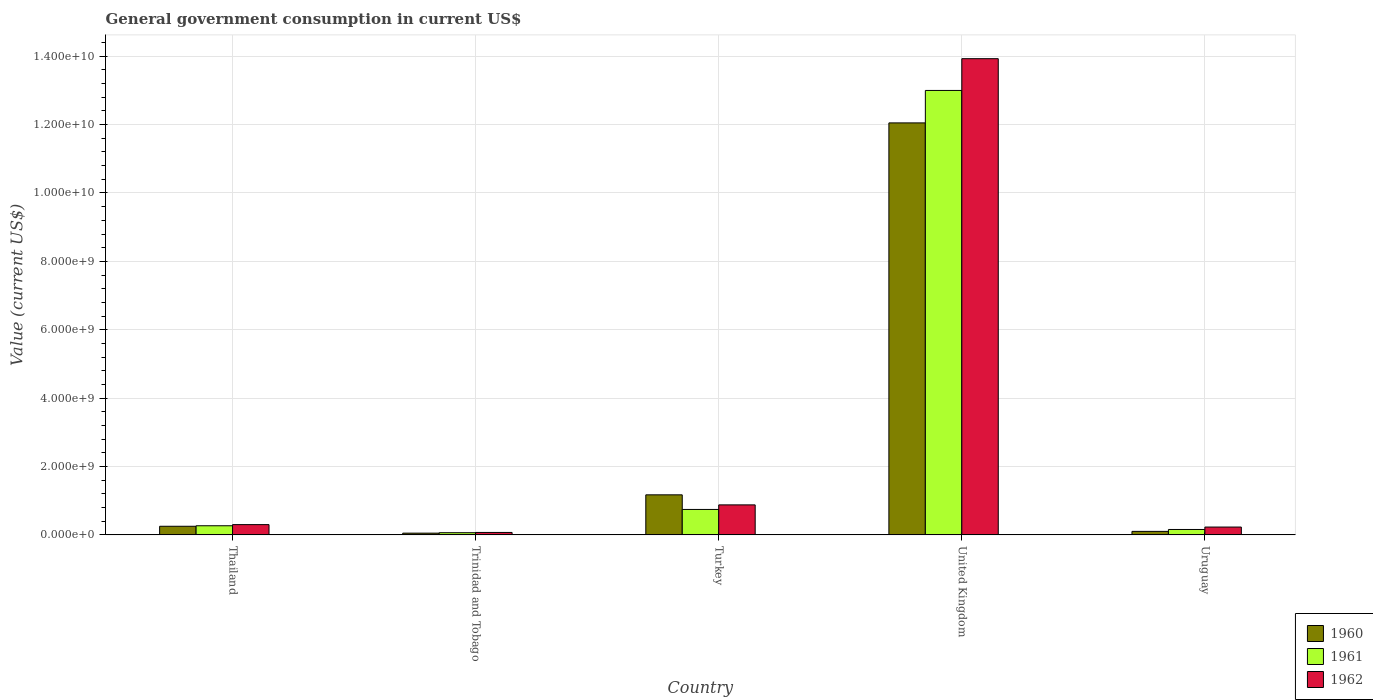How many different coloured bars are there?
Offer a terse response. 3. Are the number of bars on each tick of the X-axis equal?
Your answer should be very brief. Yes. How many bars are there on the 5th tick from the left?
Offer a terse response. 3. What is the government conusmption in 1961 in Uruguay?
Your response must be concise. 1.58e+08. Across all countries, what is the maximum government conusmption in 1961?
Provide a short and direct response. 1.30e+1. Across all countries, what is the minimum government conusmption in 1960?
Provide a succinct answer. 5.12e+07. In which country was the government conusmption in 1961 minimum?
Offer a very short reply. Trinidad and Tobago. What is the total government conusmption in 1960 in the graph?
Make the answer very short. 1.36e+1. What is the difference between the government conusmption in 1962 in Trinidad and Tobago and that in Turkey?
Your answer should be very brief. -8.06e+08. What is the difference between the government conusmption in 1961 in Turkey and the government conusmption in 1960 in Uruguay?
Give a very brief answer. 6.42e+08. What is the average government conusmption in 1962 per country?
Your answer should be very brief. 3.08e+09. What is the difference between the government conusmption of/in 1962 and government conusmption of/in 1961 in Trinidad and Tobago?
Your answer should be compact. 7.70e+06. What is the ratio of the government conusmption in 1961 in Thailand to that in United Kingdom?
Give a very brief answer. 0.02. Is the difference between the government conusmption in 1962 in Thailand and Trinidad and Tobago greater than the difference between the government conusmption in 1961 in Thailand and Trinidad and Tobago?
Your response must be concise. Yes. What is the difference between the highest and the second highest government conusmption in 1960?
Keep it short and to the point. 9.19e+08. What is the difference between the highest and the lowest government conusmption in 1961?
Provide a short and direct response. 1.29e+1. Is the sum of the government conusmption in 1962 in Turkey and United Kingdom greater than the maximum government conusmption in 1961 across all countries?
Provide a succinct answer. Yes. What does the 1st bar from the left in United Kingdom represents?
Your answer should be very brief. 1960. What does the 3rd bar from the right in Trinidad and Tobago represents?
Offer a terse response. 1960. Is it the case that in every country, the sum of the government conusmption in 1962 and government conusmption in 1961 is greater than the government conusmption in 1960?
Provide a succinct answer. Yes. How many bars are there?
Give a very brief answer. 15. What is the difference between two consecutive major ticks on the Y-axis?
Offer a terse response. 2.00e+09. Are the values on the major ticks of Y-axis written in scientific E-notation?
Make the answer very short. Yes. Does the graph contain any zero values?
Your response must be concise. No. Where does the legend appear in the graph?
Provide a succinct answer. Bottom right. How are the legend labels stacked?
Provide a short and direct response. Vertical. What is the title of the graph?
Ensure brevity in your answer.  General government consumption in current US$. Does "2014" appear as one of the legend labels in the graph?
Your response must be concise. No. What is the label or title of the Y-axis?
Keep it short and to the point. Value (current US$). What is the Value (current US$) in 1960 in Thailand?
Ensure brevity in your answer.  2.52e+08. What is the Value (current US$) of 1961 in Thailand?
Provide a succinct answer. 2.67e+08. What is the Value (current US$) of 1962 in Thailand?
Make the answer very short. 3.01e+08. What is the Value (current US$) of 1960 in Trinidad and Tobago?
Give a very brief answer. 5.12e+07. What is the Value (current US$) of 1961 in Trinidad and Tobago?
Offer a terse response. 6.39e+07. What is the Value (current US$) of 1962 in Trinidad and Tobago?
Provide a short and direct response. 7.16e+07. What is the Value (current US$) in 1960 in Turkey?
Offer a very short reply. 1.17e+09. What is the Value (current US$) in 1961 in Turkey?
Make the answer very short. 7.44e+08. What is the Value (current US$) of 1962 in Turkey?
Your answer should be very brief. 8.78e+08. What is the Value (current US$) in 1960 in United Kingdom?
Provide a succinct answer. 1.20e+1. What is the Value (current US$) in 1961 in United Kingdom?
Your answer should be very brief. 1.30e+1. What is the Value (current US$) in 1962 in United Kingdom?
Give a very brief answer. 1.39e+1. What is the Value (current US$) of 1960 in Uruguay?
Offer a terse response. 1.03e+08. What is the Value (current US$) of 1961 in Uruguay?
Make the answer very short. 1.58e+08. What is the Value (current US$) in 1962 in Uruguay?
Your response must be concise. 2.29e+08. Across all countries, what is the maximum Value (current US$) of 1960?
Offer a terse response. 1.20e+1. Across all countries, what is the maximum Value (current US$) in 1961?
Ensure brevity in your answer.  1.30e+1. Across all countries, what is the maximum Value (current US$) in 1962?
Provide a short and direct response. 1.39e+1. Across all countries, what is the minimum Value (current US$) of 1960?
Ensure brevity in your answer.  5.12e+07. Across all countries, what is the minimum Value (current US$) of 1961?
Your answer should be very brief. 6.39e+07. Across all countries, what is the minimum Value (current US$) in 1962?
Ensure brevity in your answer.  7.16e+07. What is the total Value (current US$) of 1960 in the graph?
Make the answer very short. 1.36e+1. What is the total Value (current US$) of 1961 in the graph?
Offer a very short reply. 1.42e+1. What is the total Value (current US$) in 1962 in the graph?
Your answer should be compact. 1.54e+1. What is the difference between the Value (current US$) in 1960 in Thailand and that in Trinidad and Tobago?
Provide a succinct answer. 2.01e+08. What is the difference between the Value (current US$) in 1961 in Thailand and that in Trinidad and Tobago?
Your answer should be compact. 2.03e+08. What is the difference between the Value (current US$) of 1962 in Thailand and that in Trinidad and Tobago?
Offer a terse response. 2.29e+08. What is the difference between the Value (current US$) of 1960 in Thailand and that in Turkey?
Provide a succinct answer. -9.19e+08. What is the difference between the Value (current US$) in 1961 in Thailand and that in Turkey?
Your answer should be very brief. -4.77e+08. What is the difference between the Value (current US$) of 1962 in Thailand and that in Turkey?
Make the answer very short. -5.77e+08. What is the difference between the Value (current US$) of 1960 in Thailand and that in United Kingdom?
Ensure brevity in your answer.  -1.18e+1. What is the difference between the Value (current US$) of 1961 in Thailand and that in United Kingdom?
Your response must be concise. -1.27e+1. What is the difference between the Value (current US$) of 1962 in Thailand and that in United Kingdom?
Provide a short and direct response. -1.36e+1. What is the difference between the Value (current US$) in 1960 in Thailand and that in Uruguay?
Make the answer very short. 1.49e+08. What is the difference between the Value (current US$) of 1961 in Thailand and that in Uruguay?
Offer a terse response. 1.09e+08. What is the difference between the Value (current US$) in 1962 in Thailand and that in Uruguay?
Your answer should be compact. 7.16e+07. What is the difference between the Value (current US$) of 1960 in Trinidad and Tobago and that in Turkey?
Give a very brief answer. -1.12e+09. What is the difference between the Value (current US$) of 1961 in Trinidad and Tobago and that in Turkey?
Offer a very short reply. -6.81e+08. What is the difference between the Value (current US$) in 1962 in Trinidad and Tobago and that in Turkey?
Your response must be concise. -8.06e+08. What is the difference between the Value (current US$) of 1960 in Trinidad and Tobago and that in United Kingdom?
Your answer should be very brief. -1.20e+1. What is the difference between the Value (current US$) in 1961 in Trinidad and Tobago and that in United Kingdom?
Offer a very short reply. -1.29e+1. What is the difference between the Value (current US$) of 1962 in Trinidad and Tobago and that in United Kingdom?
Your answer should be very brief. -1.39e+1. What is the difference between the Value (current US$) in 1960 in Trinidad and Tobago and that in Uruguay?
Your answer should be very brief. -5.16e+07. What is the difference between the Value (current US$) in 1961 in Trinidad and Tobago and that in Uruguay?
Your answer should be compact. -9.44e+07. What is the difference between the Value (current US$) in 1962 in Trinidad and Tobago and that in Uruguay?
Give a very brief answer. -1.58e+08. What is the difference between the Value (current US$) in 1960 in Turkey and that in United Kingdom?
Provide a short and direct response. -1.09e+1. What is the difference between the Value (current US$) in 1961 in Turkey and that in United Kingdom?
Offer a very short reply. -1.23e+1. What is the difference between the Value (current US$) of 1962 in Turkey and that in United Kingdom?
Your response must be concise. -1.30e+1. What is the difference between the Value (current US$) of 1960 in Turkey and that in Uruguay?
Make the answer very short. 1.07e+09. What is the difference between the Value (current US$) in 1961 in Turkey and that in Uruguay?
Provide a short and direct response. 5.86e+08. What is the difference between the Value (current US$) in 1962 in Turkey and that in Uruguay?
Give a very brief answer. 6.49e+08. What is the difference between the Value (current US$) of 1960 in United Kingdom and that in Uruguay?
Your answer should be very brief. 1.19e+1. What is the difference between the Value (current US$) in 1961 in United Kingdom and that in Uruguay?
Provide a short and direct response. 1.28e+1. What is the difference between the Value (current US$) of 1962 in United Kingdom and that in Uruguay?
Your response must be concise. 1.37e+1. What is the difference between the Value (current US$) of 1960 in Thailand and the Value (current US$) of 1961 in Trinidad and Tobago?
Your answer should be compact. 1.88e+08. What is the difference between the Value (current US$) in 1960 in Thailand and the Value (current US$) in 1962 in Trinidad and Tobago?
Provide a succinct answer. 1.81e+08. What is the difference between the Value (current US$) of 1961 in Thailand and the Value (current US$) of 1962 in Trinidad and Tobago?
Give a very brief answer. 1.96e+08. What is the difference between the Value (current US$) in 1960 in Thailand and the Value (current US$) in 1961 in Turkey?
Offer a very short reply. -4.92e+08. What is the difference between the Value (current US$) in 1960 in Thailand and the Value (current US$) in 1962 in Turkey?
Keep it short and to the point. -6.26e+08. What is the difference between the Value (current US$) of 1961 in Thailand and the Value (current US$) of 1962 in Turkey?
Provide a succinct answer. -6.11e+08. What is the difference between the Value (current US$) of 1960 in Thailand and the Value (current US$) of 1961 in United Kingdom?
Provide a succinct answer. -1.27e+1. What is the difference between the Value (current US$) of 1960 in Thailand and the Value (current US$) of 1962 in United Kingdom?
Offer a very short reply. -1.37e+1. What is the difference between the Value (current US$) of 1961 in Thailand and the Value (current US$) of 1962 in United Kingdom?
Your response must be concise. -1.37e+1. What is the difference between the Value (current US$) in 1960 in Thailand and the Value (current US$) in 1961 in Uruguay?
Your response must be concise. 9.39e+07. What is the difference between the Value (current US$) of 1960 in Thailand and the Value (current US$) of 1962 in Uruguay?
Make the answer very short. 2.30e+07. What is the difference between the Value (current US$) of 1961 in Thailand and the Value (current US$) of 1962 in Uruguay?
Give a very brief answer. 3.80e+07. What is the difference between the Value (current US$) of 1960 in Trinidad and Tobago and the Value (current US$) of 1961 in Turkey?
Offer a very short reply. -6.93e+08. What is the difference between the Value (current US$) in 1960 in Trinidad and Tobago and the Value (current US$) in 1962 in Turkey?
Your response must be concise. -8.27e+08. What is the difference between the Value (current US$) in 1961 in Trinidad and Tobago and the Value (current US$) in 1962 in Turkey?
Your answer should be very brief. -8.14e+08. What is the difference between the Value (current US$) in 1960 in Trinidad and Tobago and the Value (current US$) in 1961 in United Kingdom?
Provide a succinct answer. -1.29e+1. What is the difference between the Value (current US$) of 1960 in Trinidad and Tobago and the Value (current US$) of 1962 in United Kingdom?
Make the answer very short. -1.39e+1. What is the difference between the Value (current US$) of 1961 in Trinidad and Tobago and the Value (current US$) of 1962 in United Kingdom?
Your response must be concise. -1.39e+1. What is the difference between the Value (current US$) in 1960 in Trinidad and Tobago and the Value (current US$) in 1961 in Uruguay?
Offer a terse response. -1.07e+08. What is the difference between the Value (current US$) of 1960 in Trinidad and Tobago and the Value (current US$) of 1962 in Uruguay?
Keep it short and to the point. -1.78e+08. What is the difference between the Value (current US$) of 1961 in Trinidad and Tobago and the Value (current US$) of 1962 in Uruguay?
Offer a terse response. -1.65e+08. What is the difference between the Value (current US$) of 1960 in Turkey and the Value (current US$) of 1961 in United Kingdom?
Provide a succinct answer. -1.18e+1. What is the difference between the Value (current US$) of 1960 in Turkey and the Value (current US$) of 1962 in United Kingdom?
Your response must be concise. -1.28e+1. What is the difference between the Value (current US$) in 1961 in Turkey and the Value (current US$) in 1962 in United Kingdom?
Keep it short and to the point. -1.32e+1. What is the difference between the Value (current US$) in 1960 in Turkey and the Value (current US$) in 1961 in Uruguay?
Your answer should be very brief. 1.01e+09. What is the difference between the Value (current US$) in 1960 in Turkey and the Value (current US$) in 1962 in Uruguay?
Offer a terse response. 9.42e+08. What is the difference between the Value (current US$) in 1961 in Turkey and the Value (current US$) in 1962 in Uruguay?
Keep it short and to the point. 5.15e+08. What is the difference between the Value (current US$) of 1960 in United Kingdom and the Value (current US$) of 1961 in Uruguay?
Make the answer very short. 1.19e+1. What is the difference between the Value (current US$) of 1960 in United Kingdom and the Value (current US$) of 1962 in Uruguay?
Provide a short and direct response. 1.18e+1. What is the difference between the Value (current US$) of 1961 in United Kingdom and the Value (current US$) of 1962 in Uruguay?
Make the answer very short. 1.28e+1. What is the average Value (current US$) of 1960 per country?
Ensure brevity in your answer.  2.73e+09. What is the average Value (current US$) of 1961 per country?
Make the answer very short. 2.85e+09. What is the average Value (current US$) in 1962 per country?
Your answer should be compact. 3.08e+09. What is the difference between the Value (current US$) in 1960 and Value (current US$) in 1961 in Thailand?
Ensure brevity in your answer.  -1.50e+07. What is the difference between the Value (current US$) in 1960 and Value (current US$) in 1962 in Thailand?
Keep it short and to the point. -4.86e+07. What is the difference between the Value (current US$) of 1961 and Value (current US$) of 1962 in Thailand?
Your response must be concise. -3.36e+07. What is the difference between the Value (current US$) in 1960 and Value (current US$) in 1961 in Trinidad and Tobago?
Give a very brief answer. -1.27e+07. What is the difference between the Value (current US$) in 1960 and Value (current US$) in 1962 in Trinidad and Tobago?
Your answer should be very brief. -2.04e+07. What is the difference between the Value (current US$) in 1961 and Value (current US$) in 1962 in Trinidad and Tobago?
Your response must be concise. -7.70e+06. What is the difference between the Value (current US$) of 1960 and Value (current US$) of 1961 in Turkey?
Your answer should be compact. 4.27e+08. What is the difference between the Value (current US$) in 1960 and Value (current US$) in 1962 in Turkey?
Make the answer very short. 2.94e+08. What is the difference between the Value (current US$) in 1961 and Value (current US$) in 1962 in Turkey?
Give a very brief answer. -1.33e+08. What is the difference between the Value (current US$) of 1960 and Value (current US$) of 1961 in United Kingdom?
Provide a succinct answer. -9.49e+08. What is the difference between the Value (current US$) of 1960 and Value (current US$) of 1962 in United Kingdom?
Your response must be concise. -1.88e+09. What is the difference between the Value (current US$) of 1961 and Value (current US$) of 1962 in United Kingdom?
Provide a short and direct response. -9.29e+08. What is the difference between the Value (current US$) in 1960 and Value (current US$) in 1961 in Uruguay?
Your answer should be compact. -5.54e+07. What is the difference between the Value (current US$) in 1960 and Value (current US$) in 1962 in Uruguay?
Provide a succinct answer. -1.26e+08. What is the difference between the Value (current US$) of 1961 and Value (current US$) of 1962 in Uruguay?
Keep it short and to the point. -7.09e+07. What is the ratio of the Value (current US$) of 1960 in Thailand to that in Trinidad and Tobago?
Your response must be concise. 4.92. What is the ratio of the Value (current US$) of 1961 in Thailand to that in Trinidad and Tobago?
Make the answer very short. 4.18. What is the ratio of the Value (current US$) of 1962 in Thailand to that in Trinidad and Tobago?
Offer a terse response. 4.2. What is the ratio of the Value (current US$) in 1960 in Thailand to that in Turkey?
Give a very brief answer. 0.22. What is the ratio of the Value (current US$) in 1961 in Thailand to that in Turkey?
Offer a terse response. 0.36. What is the ratio of the Value (current US$) of 1962 in Thailand to that in Turkey?
Ensure brevity in your answer.  0.34. What is the ratio of the Value (current US$) in 1960 in Thailand to that in United Kingdom?
Offer a terse response. 0.02. What is the ratio of the Value (current US$) in 1961 in Thailand to that in United Kingdom?
Keep it short and to the point. 0.02. What is the ratio of the Value (current US$) of 1962 in Thailand to that in United Kingdom?
Your response must be concise. 0.02. What is the ratio of the Value (current US$) of 1960 in Thailand to that in Uruguay?
Offer a terse response. 2.45. What is the ratio of the Value (current US$) of 1961 in Thailand to that in Uruguay?
Provide a succinct answer. 1.69. What is the ratio of the Value (current US$) of 1962 in Thailand to that in Uruguay?
Offer a terse response. 1.31. What is the ratio of the Value (current US$) in 1960 in Trinidad and Tobago to that in Turkey?
Offer a very short reply. 0.04. What is the ratio of the Value (current US$) in 1961 in Trinidad and Tobago to that in Turkey?
Your answer should be compact. 0.09. What is the ratio of the Value (current US$) in 1962 in Trinidad and Tobago to that in Turkey?
Provide a succinct answer. 0.08. What is the ratio of the Value (current US$) of 1960 in Trinidad and Tobago to that in United Kingdom?
Your answer should be very brief. 0. What is the ratio of the Value (current US$) of 1961 in Trinidad and Tobago to that in United Kingdom?
Your answer should be very brief. 0. What is the ratio of the Value (current US$) in 1962 in Trinidad and Tobago to that in United Kingdom?
Make the answer very short. 0.01. What is the ratio of the Value (current US$) in 1960 in Trinidad and Tobago to that in Uruguay?
Give a very brief answer. 0.5. What is the ratio of the Value (current US$) of 1961 in Trinidad and Tobago to that in Uruguay?
Ensure brevity in your answer.  0.4. What is the ratio of the Value (current US$) in 1962 in Trinidad and Tobago to that in Uruguay?
Make the answer very short. 0.31. What is the ratio of the Value (current US$) of 1960 in Turkey to that in United Kingdom?
Make the answer very short. 0.1. What is the ratio of the Value (current US$) in 1961 in Turkey to that in United Kingdom?
Make the answer very short. 0.06. What is the ratio of the Value (current US$) in 1962 in Turkey to that in United Kingdom?
Make the answer very short. 0.06. What is the ratio of the Value (current US$) in 1960 in Turkey to that in Uruguay?
Provide a short and direct response. 11.39. What is the ratio of the Value (current US$) in 1961 in Turkey to that in Uruguay?
Offer a terse response. 4.7. What is the ratio of the Value (current US$) in 1962 in Turkey to that in Uruguay?
Make the answer very short. 3.83. What is the ratio of the Value (current US$) in 1960 in United Kingdom to that in Uruguay?
Offer a very short reply. 117.2. What is the ratio of the Value (current US$) of 1961 in United Kingdom to that in Uruguay?
Offer a very short reply. 82.14. What is the ratio of the Value (current US$) of 1962 in United Kingdom to that in Uruguay?
Give a very brief answer. 60.77. What is the difference between the highest and the second highest Value (current US$) in 1960?
Your answer should be compact. 1.09e+1. What is the difference between the highest and the second highest Value (current US$) in 1961?
Your answer should be very brief. 1.23e+1. What is the difference between the highest and the second highest Value (current US$) in 1962?
Your answer should be compact. 1.30e+1. What is the difference between the highest and the lowest Value (current US$) of 1960?
Your answer should be compact. 1.20e+1. What is the difference between the highest and the lowest Value (current US$) in 1961?
Your response must be concise. 1.29e+1. What is the difference between the highest and the lowest Value (current US$) of 1962?
Give a very brief answer. 1.39e+1. 